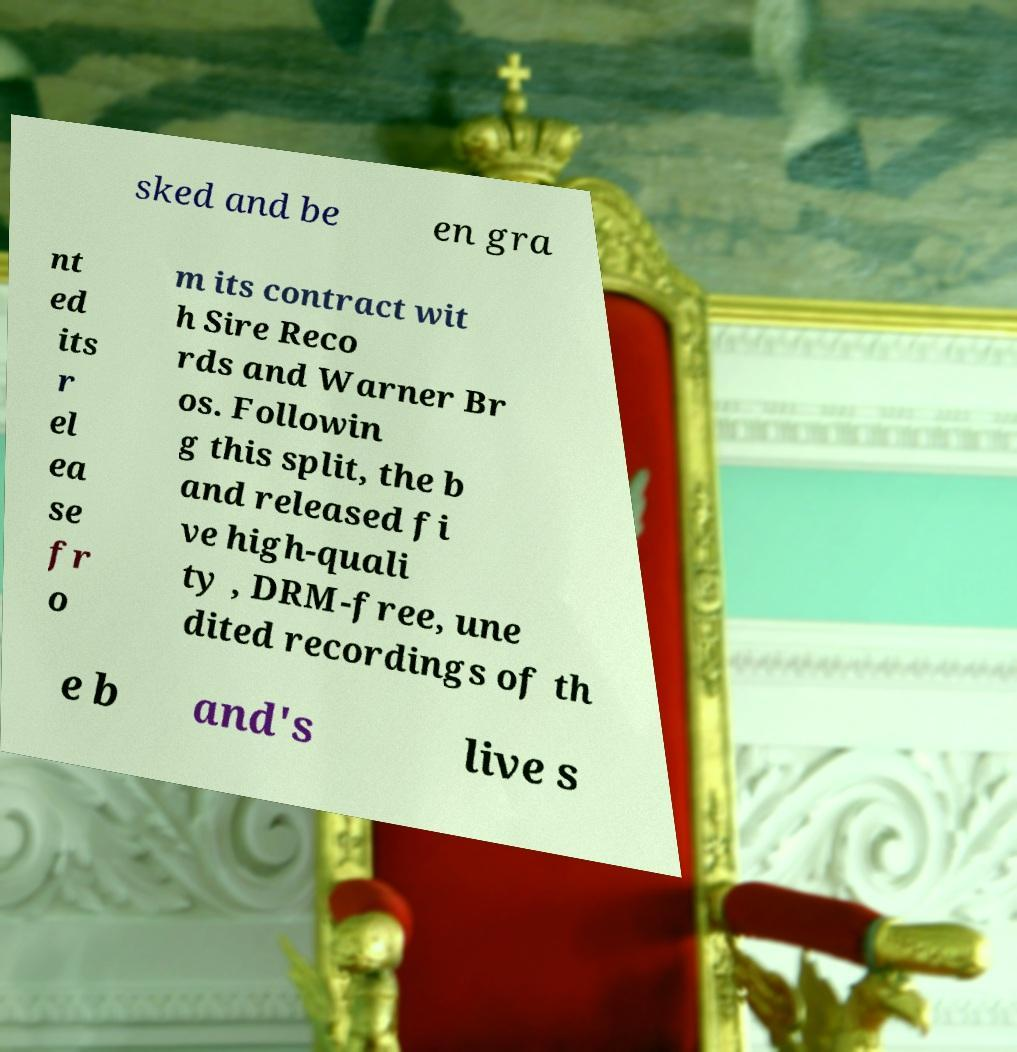Could you assist in decoding the text presented in this image and type it out clearly? sked and be en gra nt ed its r el ea se fr o m its contract wit h Sire Reco rds and Warner Br os. Followin g this split, the b and released fi ve high-quali ty , DRM-free, une dited recordings of th e b and's live s 